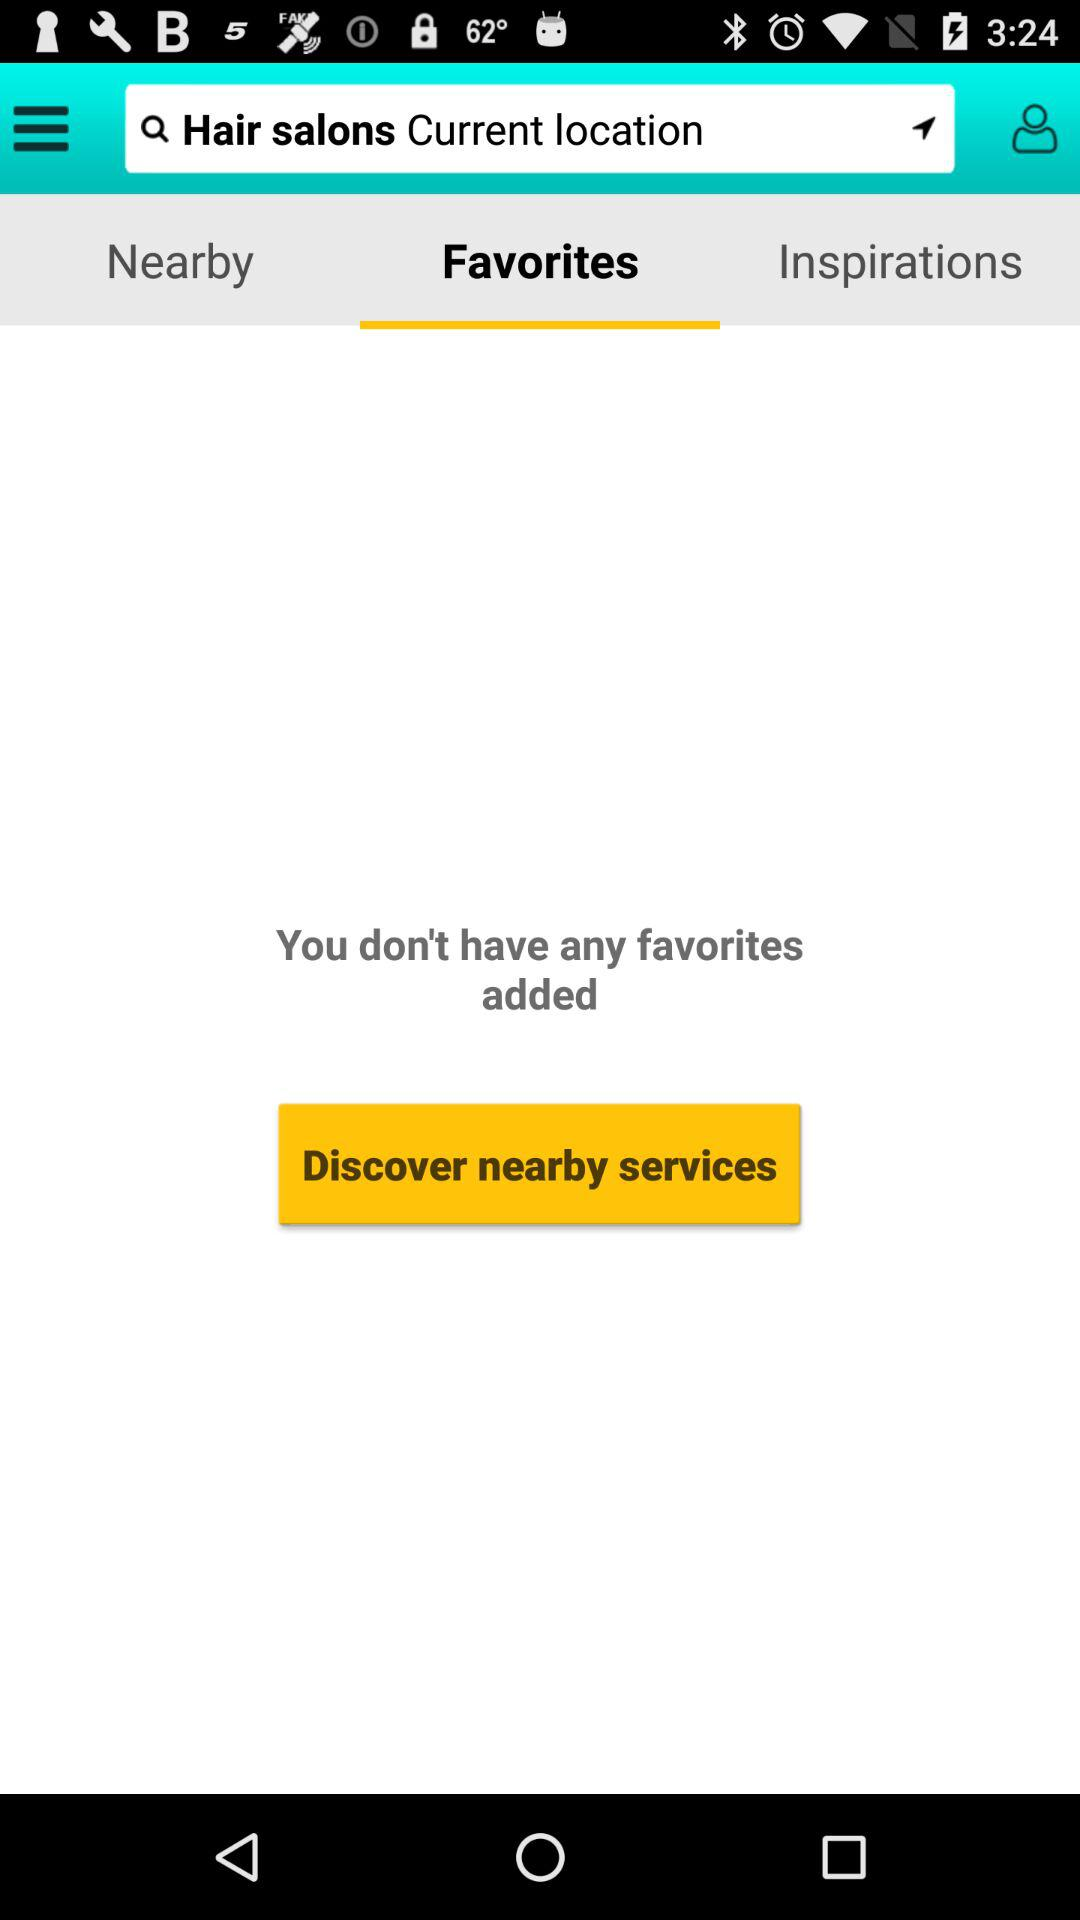Which location is in the search bar?
When the provided information is insufficient, respond with <no answer>. <no answer> 